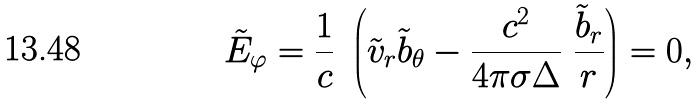Convert formula to latex. <formula><loc_0><loc_0><loc_500><loc_500>\tilde { E } _ { \varphi } = \frac { 1 } { c } \ \left ( \tilde { v } _ { r } \tilde { b } _ { \theta } - \frac { c ^ { 2 } } { 4 \pi \sigma \Delta } \ \frac { \tilde { b } _ { r } } { r } \right ) = 0 ,</formula> 